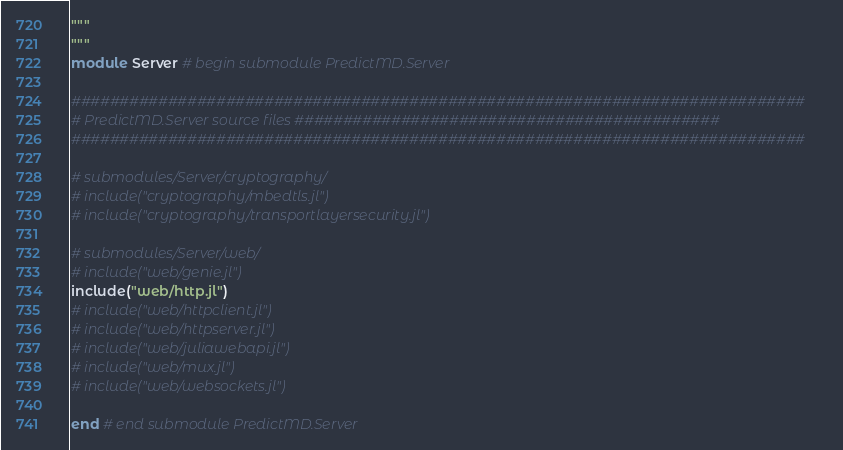Convert code to text. <code><loc_0><loc_0><loc_500><loc_500><_Julia_>"""
"""
module Server # begin submodule PredictMD.Server

############################################################################
# PredictMD.Server source files ############################################
############################################################################

# submodules/Server/cryptography/
# include("cryptography/mbedtls.jl")
# include("cryptography/transportlayersecurity.jl")

# submodules/Server/web/
# include("web/genie.jl")
include("web/http.jl")
# include("web/httpclient.jl")
# include("web/httpserver.jl")
# include("web/juliawebapi.jl")
# include("web/mux.jl")
# include("web/websockets.jl")

end # end submodule PredictMD.Server
</code> 